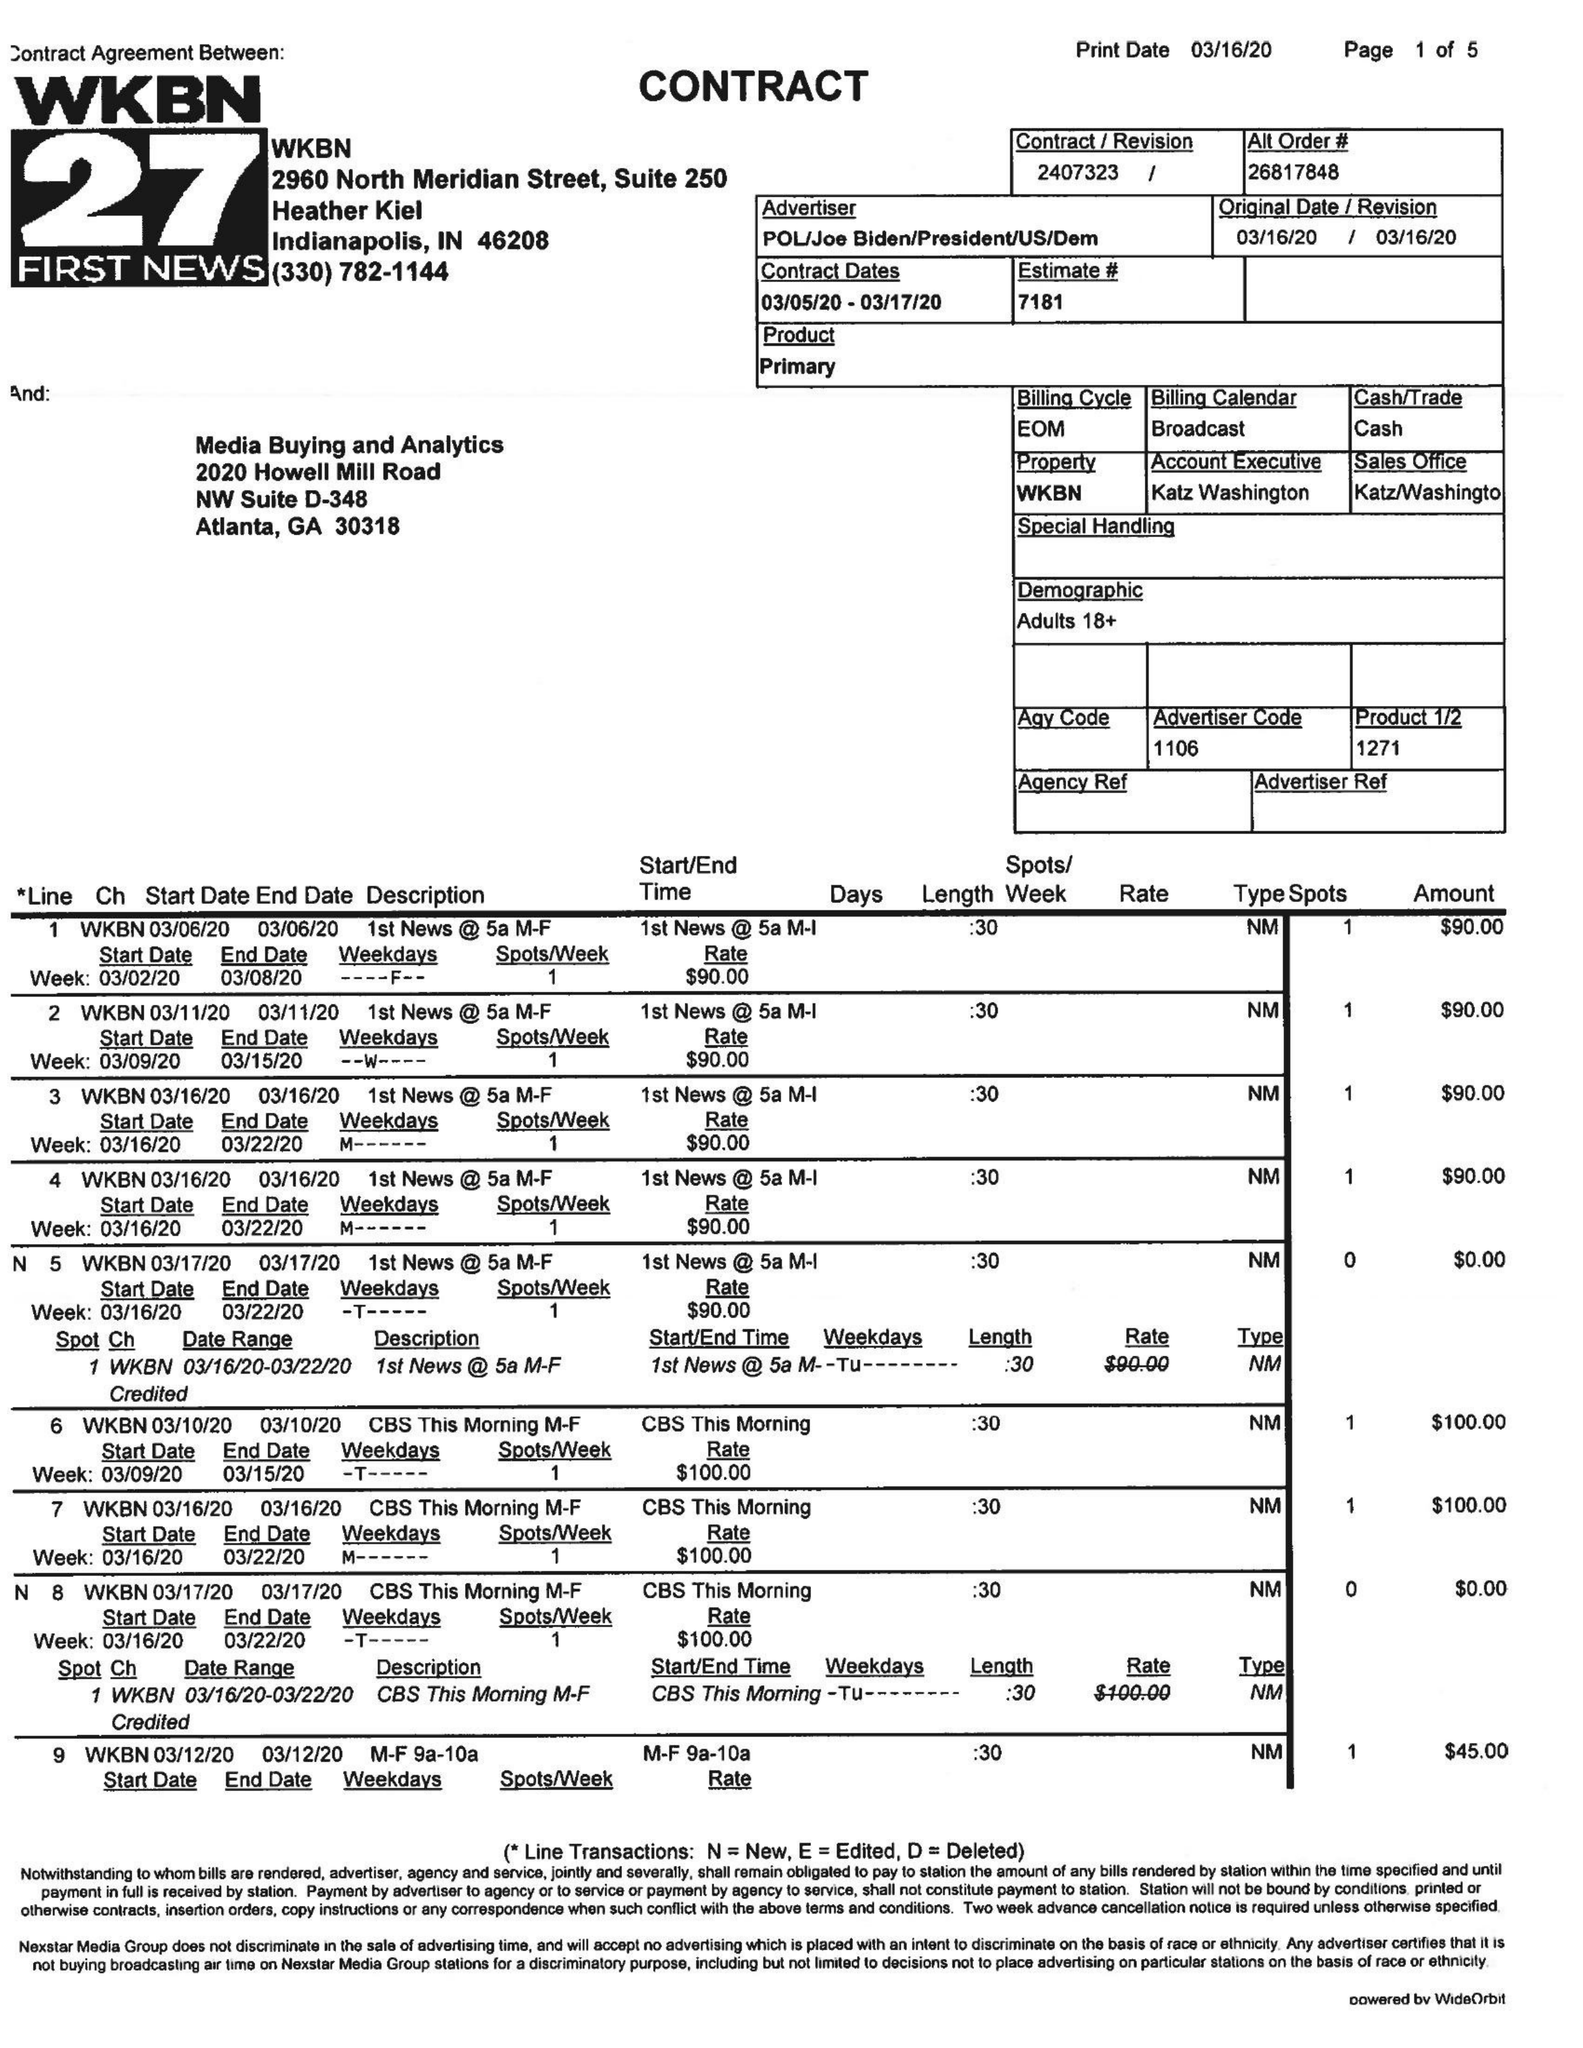What is the value for the advertiser?
Answer the question using a single word or phrase. POL/JOEBIDEN/PRESIDENT/US/DEM 